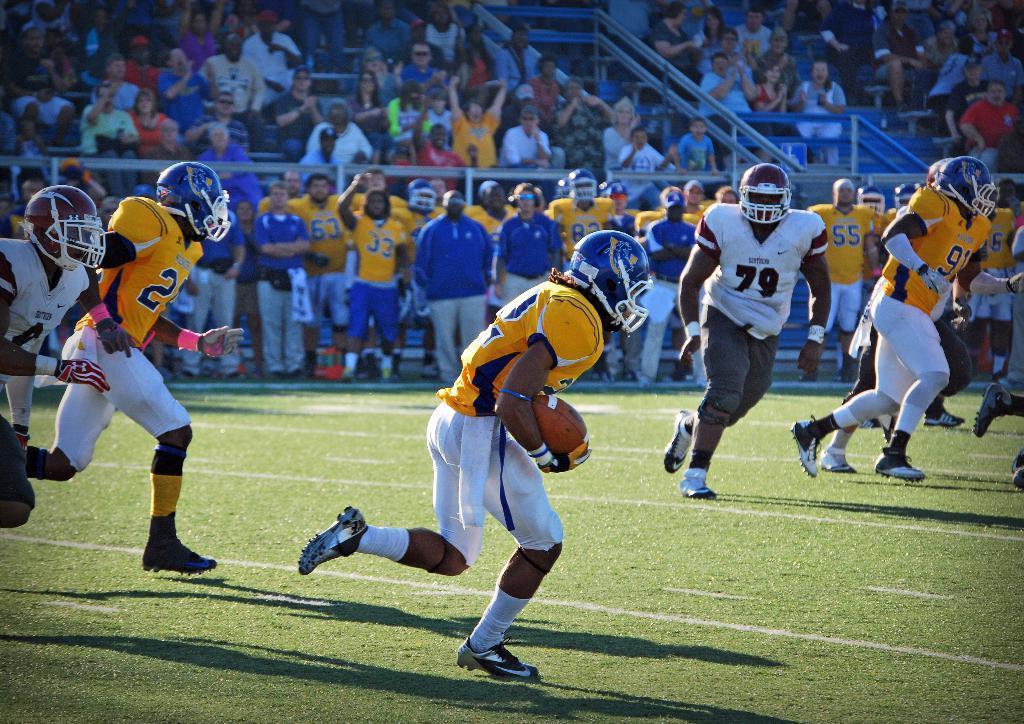Please provide a concise description of this image. This image is clicked in a ground where there are so many paper sitting on stairs and watching the match. There are so many people in the middle who are standing and in the front there are people who are playing game. One of them has a ball in his hand. They are wearing helmets shoes and white color pant. 